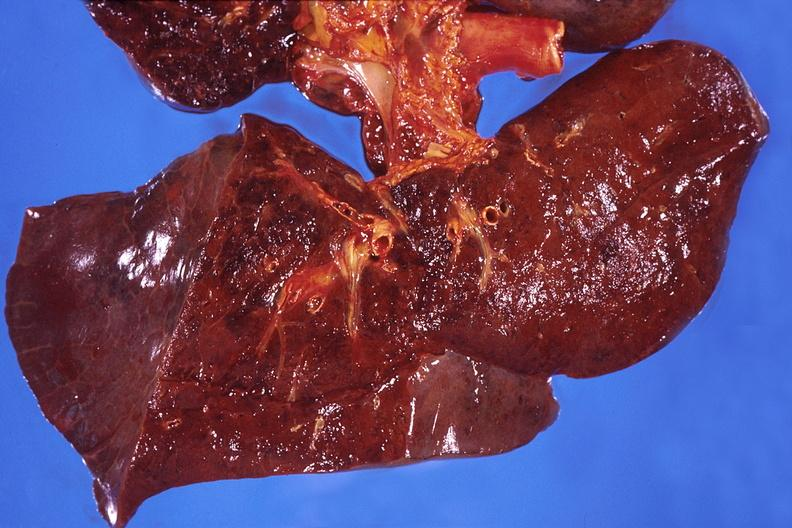what is present?
Answer the question using a single word or phrase. Respiratory 